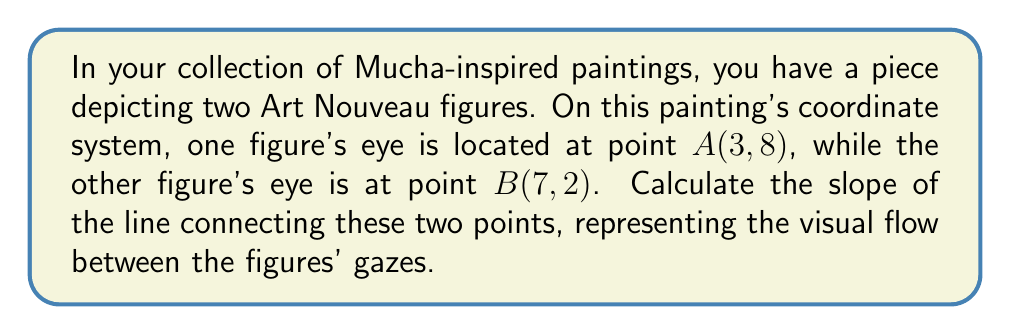Teach me how to tackle this problem. To calculate the slope of a line connecting two points, we use the slope formula:

$$ m = \frac{y_2 - y_1}{x_2 - x_1} $$

Where $(x_1, y_1)$ represents the coordinates of the first point and $(x_2, y_2)$ represents the coordinates of the second point.

In this case:
Point A: $(x_1, y_1) = (3, 8)$
Point B: $(x_2, y_2) = (7, 2)$

Substituting these values into the slope formula:

$$ m = \frac{2 - 8}{7 - 3} = \frac{-6}{4} $$

Simplifying the fraction:

$$ m = -\frac{3}{2} = -1.5 $$

The negative slope indicates that the line descends from left to right, which aligns with the Art Nouveau style's flowing, organic lines often found in Mucha's works.
Answer: $-\frac{3}{2}$ or $-1.5$ 